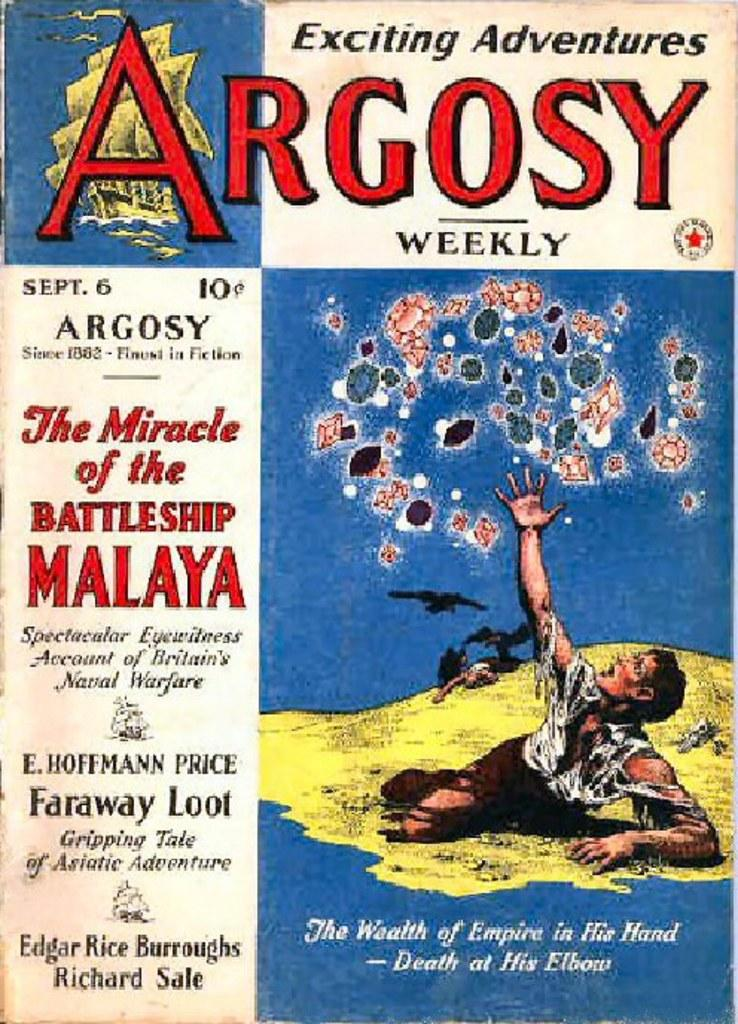<image>
Describe the image concisely. A cover for the Exciting Adventures Argosy Weekly. 